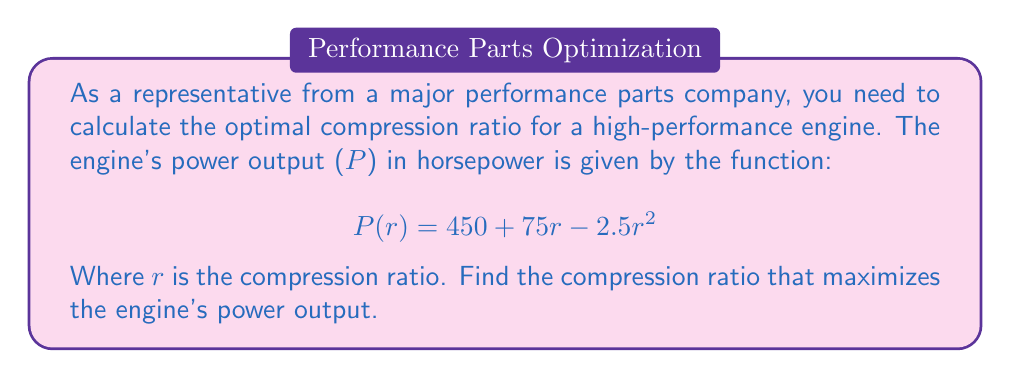What is the answer to this math problem? To find the optimal compression ratio that maximizes the engine's power output, we need to follow these steps:

1) The given function represents a quadratic equation. The maximum or minimum of a quadratic function occurs at the vertex of the parabola.

2) For a quadratic function in the form $f(x) = ax^2 + bx + c$, the x-coordinate of the vertex is given by $x = -\frac{b}{2a}$.

3) In our case, $P(r) = 450 + 75r - 2.5r^2$. Comparing this to the standard form:

   $a = -2.5$
   $b = 75$
   $c = 450$

4) Using the formula for the vertex:

   $$r = -\frac{b}{2a} = -\frac{75}{2(-2.5)} = -\frac{75}{-5} = 15$$

5) To confirm this is a maximum (not a minimum), we can check the sign of 'a':
   Since $a = -2.5 < 0$, the parabola opens downward, confirming this is indeed a maximum.

6) Therefore, the power output is maximized when the compression ratio is 15:1.

To find the maximum power output, we can substitute r = 15 into the original function:

$$P(15) = 450 + 75(15) - 2.5(15)^2 = 450 + 1125 - 562.5 = 1012.5$$

Thus, the maximum power output is 1012.5 horsepower.
Answer: The optimal compression ratio for maximum engine performance is 15:1, which yields a maximum power output of 1012.5 horsepower. 